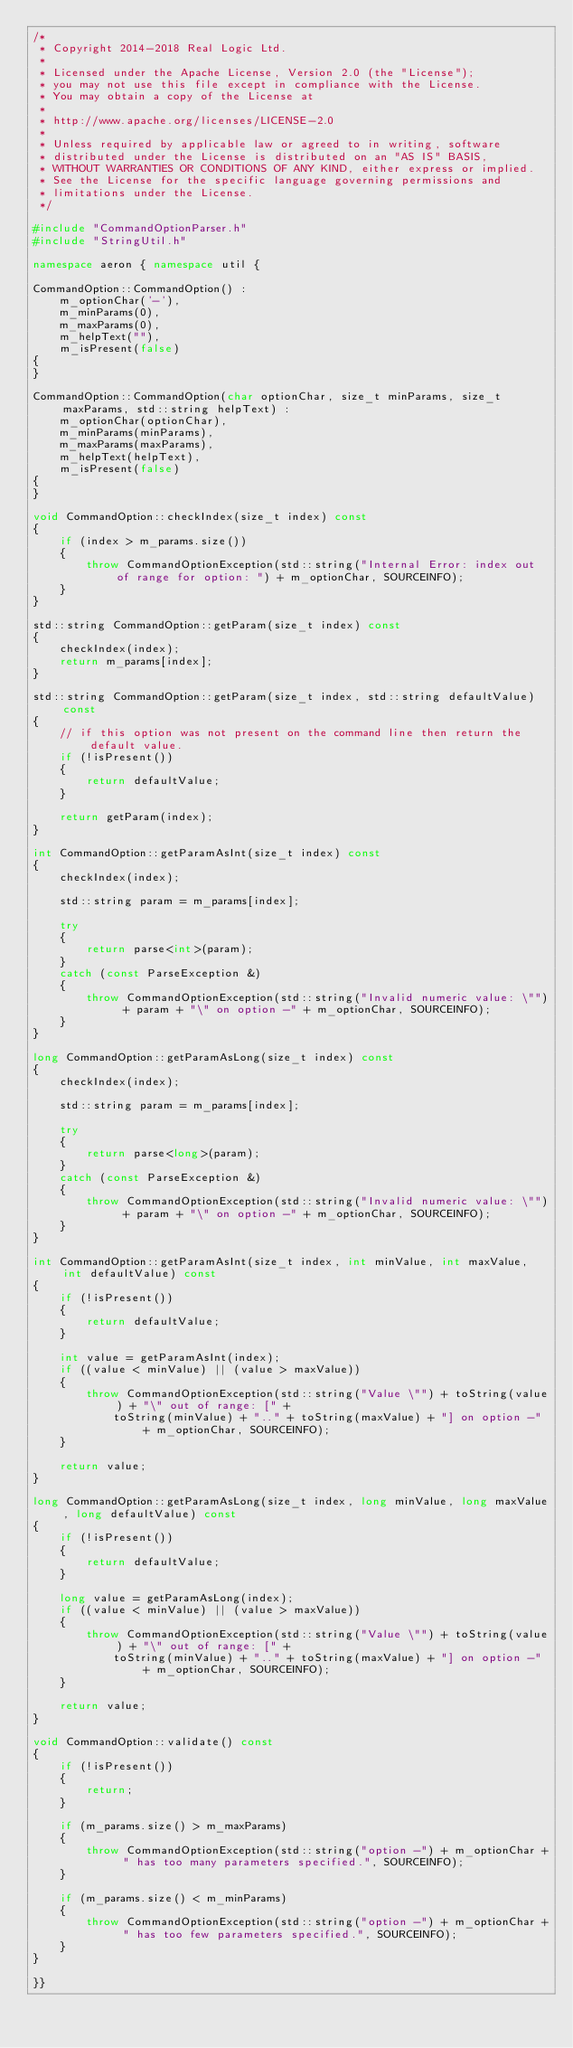Convert code to text. <code><loc_0><loc_0><loc_500><loc_500><_C++_>/*
 * Copyright 2014-2018 Real Logic Ltd.
 *
 * Licensed under the Apache License, Version 2.0 (the "License");
 * you may not use this file except in compliance with the License.
 * You may obtain a copy of the License at
 *
 * http://www.apache.org/licenses/LICENSE-2.0
 *
 * Unless required by applicable law or agreed to in writing, software
 * distributed under the License is distributed on an "AS IS" BASIS,
 * WITHOUT WARRANTIES OR CONDITIONS OF ANY KIND, either express or implied.
 * See the License for the specific language governing permissions and
 * limitations under the License.
 */

#include "CommandOptionParser.h"
#include "StringUtil.h"

namespace aeron { namespace util {

CommandOption::CommandOption() :
    m_optionChar('-'),
    m_minParams(0),
    m_maxParams(0),
    m_helpText(""),
    m_isPresent(false)
{
}

CommandOption::CommandOption(char optionChar, size_t minParams, size_t maxParams, std::string helpText) :
    m_optionChar(optionChar),
    m_minParams(minParams),
    m_maxParams(maxParams),
    m_helpText(helpText),
    m_isPresent(false)
{
}

void CommandOption::checkIndex(size_t index) const
{
    if (index > m_params.size())
    {
        throw CommandOptionException(std::string("Internal Error: index out of range for option: ") + m_optionChar, SOURCEINFO);
    }
}

std::string CommandOption::getParam(size_t index) const
{
    checkIndex(index);
    return m_params[index];
}

std::string CommandOption::getParam(size_t index, std::string defaultValue) const
{
    // if this option was not present on the command line then return the default value.
    if (!isPresent())
    {
        return defaultValue;
    }

    return getParam(index);
}

int CommandOption::getParamAsInt(size_t index) const
{
    checkIndex(index);

    std::string param = m_params[index];

    try
    {
        return parse<int>(param);
    }
    catch (const ParseException &)
    {
        throw CommandOptionException(std::string("Invalid numeric value: \"") + param + "\" on option -" + m_optionChar, SOURCEINFO);
    }
}

long CommandOption::getParamAsLong(size_t index) const
{
    checkIndex(index);

    std::string param = m_params[index];

    try
    {
        return parse<long>(param);
    }
    catch (const ParseException &)
    {
        throw CommandOptionException(std::string("Invalid numeric value: \"") + param + "\" on option -" + m_optionChar, SOURCEINFO);
    }
}

int CommandOption::getParamAsInt(size_t index, int minValue, int maxValue, int defaultValue) const
{
    if (!isPresent())
    {
        return defaultValue;
    }

    int value = getParamAsInt(index);
    if ((value < minValue) || (value > maxValue))
    {
        throw CommandOptionException(std::string("Value \"") + toString(value) + "\" out of range: [" +
            toString(minValue) + ".." + toString(maxValue) + "] on option -" + m_optionChar, SOURCEINFO);
    }

    return value;
}

long CommandOption::getParamAsLong(size_t index, long minValue, long maxValue, long defaultValue) const
{
    if (!isPresent())
    {
        return defaultValue;
    }

    long value = getParamAsLong(index);
    if ((value < minValue) || (value > maxValue))
    {
        throw CommandOptionException(std::string("Value \"") + toString(value) + "\" out of range: [" +
            toString(minValue) + ".." + toString(maxValue) + "] on option -" + m_optionChar, SOURCEINFO);
    }

    return value;
}

void CommandOption::validate() const
{
    if (!isPresent())
    {
        return;
    }

    if (m_params.size() > m_maxParams)
    {
        throw CommandOptionException(std::string("option -") + m_optionChar + " has too many parameters specified.", SOURCEINFO);
    }

    if (m_params.size() < m_minParams)
    {
        throw CommandOptionException(std::string("option -") + m_optionChar + " has too few parameters specified.", SOURCEINFO);
    }
}

}}
</code> 